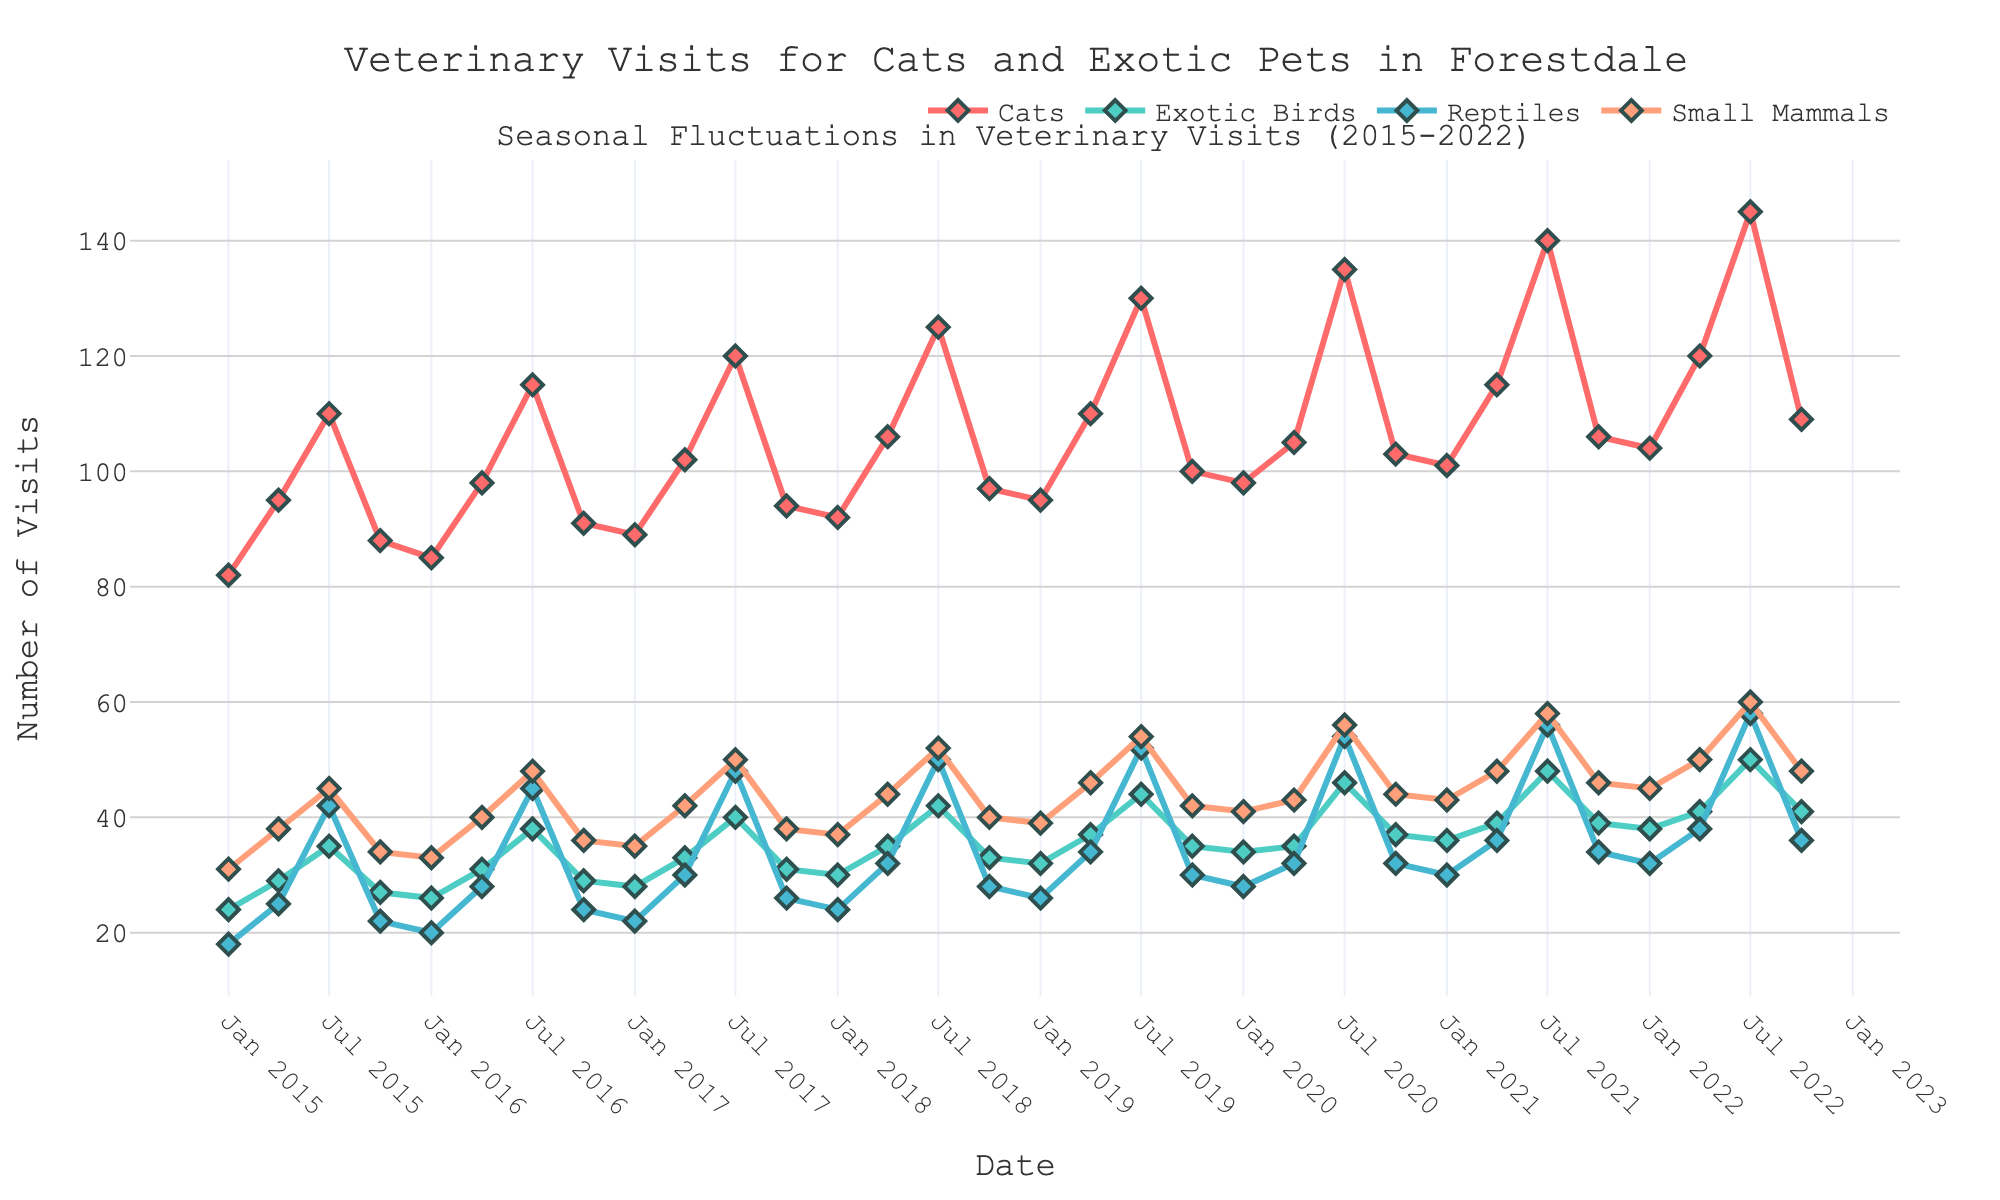What is the highest number of veterinary visits recorded for cats in any month shown in the chart? Look at the line representing cats and identify the peak point. The highest point on the chart for cats represents the maximum number of visits.
Answer: 145 How do the veterinary visit patterns in July differ between cats and small mammals over the given years? Observe the trends for both cats and small mammals during the month of July in each year. Compare the heights of the lines at each July point across the years.
Answer: Visits for cats increase more steeply and consistently each July compared to small mammals During which year and month did exotic birds reach their peak number of veterinary visits? Identify the highest point on the line representing exotic birds and note the corresponding year and month.
Answer: July 2022 Compare the veterinary visits for reptiles and small mammals in April 2018. Which had more visits, and by how much? Find the data points for both reptiles and small mammals in April 2018 and subtract the number of visits for reptiles from small mammals.
Answer: Small mammals by 12 visits What is the overall trend for veterinary visits for reptiles from 2015 to 2022? Observe the general direction of the trendline for reptiles from the beginning (2015) to the end (2022) of the chart.
Answer: Increasing How did the number of veterinary visits for small mammals change from January 2015 to October 2022? Look at the points representing small mammals in January 2015 and October 2022, then calculate the difference.
Answer: Increased by 17 visits Which pet type shows the most noticeable seasonal fluctuation, and what indicates this? Compare the amplitude of fluctuations for all lines. The line with the largest up-and-down movements indicates the most seasonal fluctuation.
Answer: Cats What can you conclude about the veterinary visits for exotic birds in October compared to July over these years? Examine the differences between the data points for exotic birds in July and October in each year and identify if there is a consistent pattern or notable change.
Answer: Visits in July are consistently higher than in October Determine the percentage increase in veterinary visits for cats from January 2020 to July 2020. Find the number of visits for cats in January 2020 and in July 2020. Use the formula [(July visits - January visits) / January visits] × 100% to calculate the percentage increase.
Answer: 37.8% Compare the veterinary visits for small mammals in January 2021 and January 2022. Look at the points for small mammals in January 2021 and January 2022, then compare the numbers directly.
Answer: Increased by 2 visits 